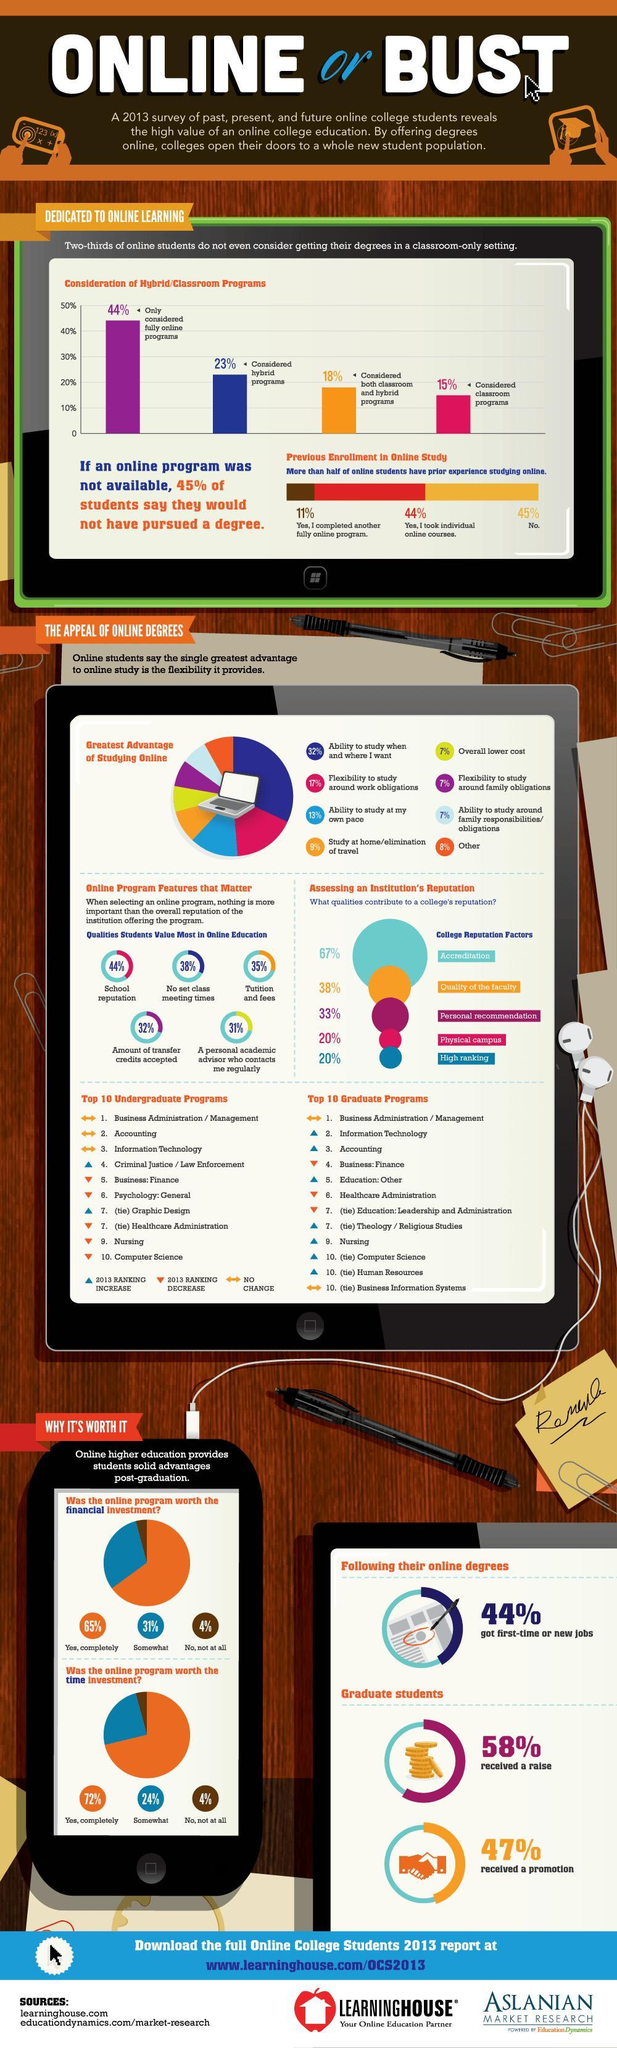What percentage of students do not agree that the online program was worth the time investment according to 2013 survey?
Answer the question with a short phrase. 4% What percentage of students completely agree that the online program was worth the time investment according to 2013 survey? 72% What percentage of students do not agree that the online program was worth the financial investment according to 2013 survey? 4% What percentage of students completely agree that the online program was worth the financial investment as per the 2013 survey? 65% What percentage of students considered hybrid programs as per the 2013 survey? 23% 